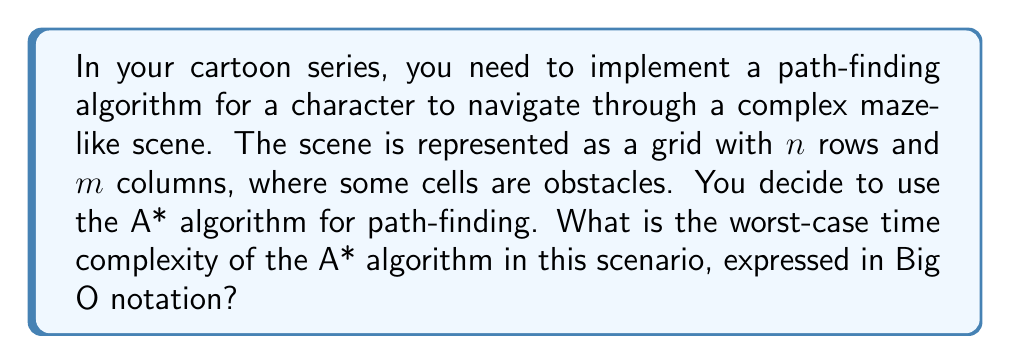Can you solve this math problem? To determine the worst-case time complexity of the A* algorithm for this scenario, let's break down the problem:

1. The search space:
   - The grid has $n$ rows and $m$ columns
   - Total number of cells = $n \times m$

2. A* algorithm components:
   - Open list: Stores nodes to be evaluated
   - Closed list: Stores already evaluated nodes
   - Heuristic function: Estimates cost from current node to goal

3. Worst-case scenario:
   - The algorithm needs to explore all cells in the grid
   - The path from start to goal is the longest possible

4. Time complexity analysis:
   a) Insertion and removal from the open list:
      - Using a binary heap, each operation takes $O(\log(nm))$
      - In the worst case, we perform these operations for each cell: $O(nm \log(nm))$

   b) Heuristic calculation:
      - Typically constant time for each node: $O(1)$
      - Performed for each cell: $O(nm)$

   c) Neighbor expansion:
      - Each cell has at most 4 neighbors (up, down, left, right)
      - Constant time operation: $O(1)$
      - Performed for each cell: $O(nm)$

5. Combining all components:
   $O(nm \log(nm)) + O(nm) + O(nm)$

6. Simplifying:
   $O(nm \log(nm))$

Therefore, the worst-case time complexity of the A* algorithm in this scenario is $O(nm \log(nm))$, where $n$ is the number of rows and $m$ is the number of columns in the grid.
Answer: $O(nm \log(nm))$ 